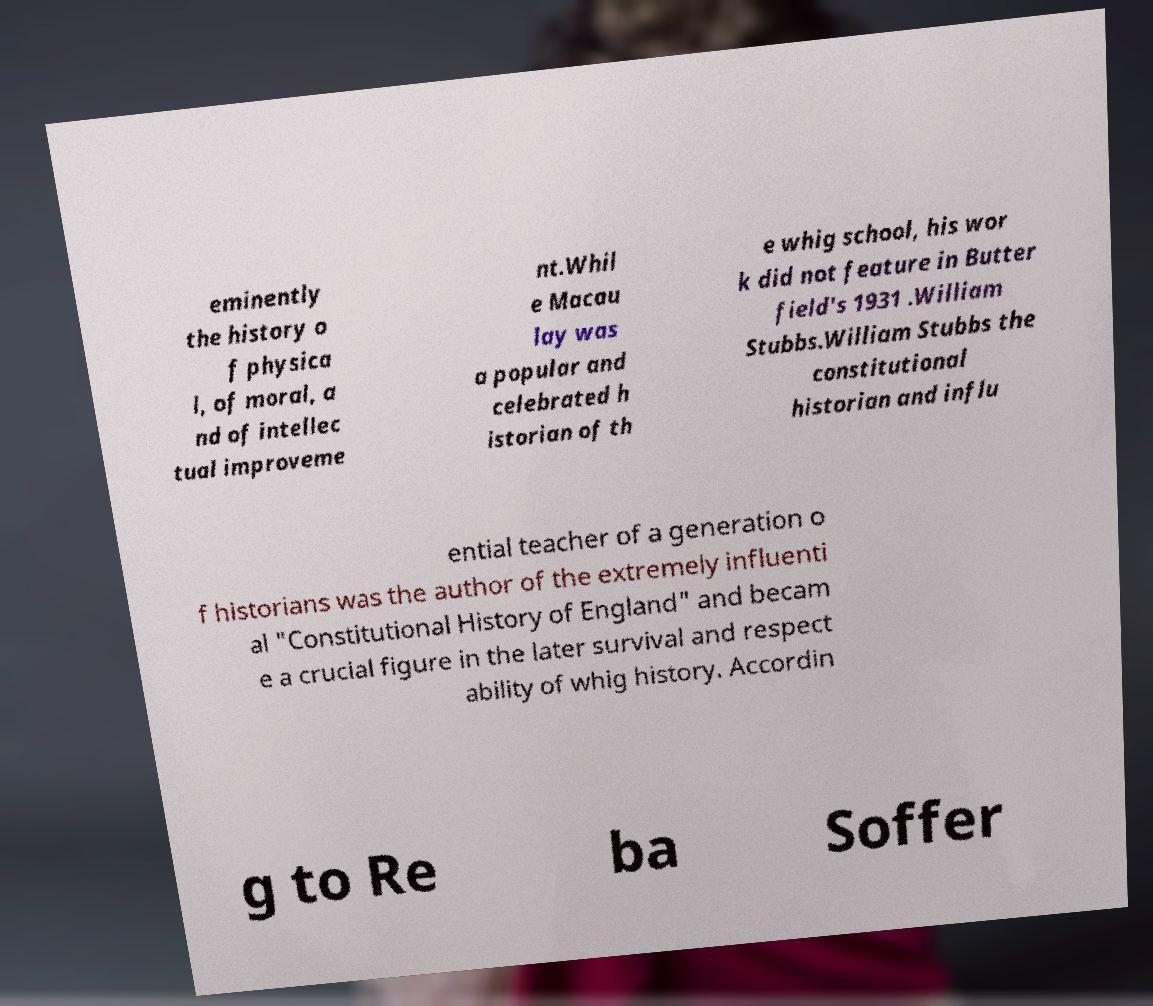I need the written content from this picture converted into text. Can you do that? eminently the history o f physica l, of moral, a nd of intellec tual improveme nt.Whil e Macau lay was a popular and celebrated h istorian of th e whig school, his wor k did not feature in Butter field's 1931 .William Stubbs.William Stubbs the constitutional historian and influ ential teacher of a generation o f historians was the author of the extremely influenti al "Constitutional History of England" and becam e a crucial figure in the later survival and respect ability of whig history. Accordin g to Re ba Soffer 